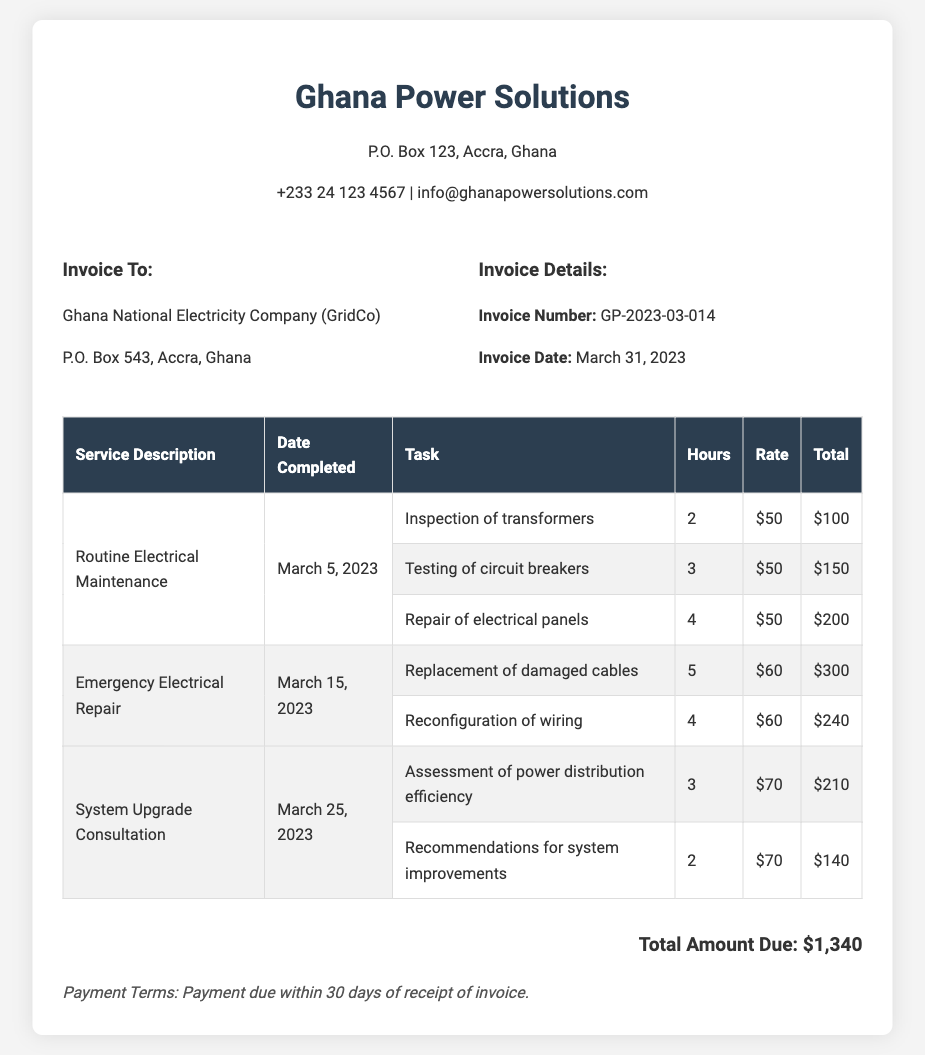What is the invoice number? The invoice number is a unique identifier for the invoice, which can be found in the invoice details section.
Answer: GP-2023-03-014 Who is the invoice addressed to? The invoice is addressed to Ghana National Electricity Company (GridCo) as seen in the invoice details.
Answer: Ghana National Electricity Company (GridCo) What is the total amount due? The total amount due is calculated from all services rendered and is stated at the bottom of the invoice.
Answer: $1,340 How many hours were spent on the inspection of transformers? The hours spent on the inspection of transformers can be found in the service details of the invoice.
Answer: 2 What date was the routine electrical maintenance completed? The date of completion for the routine electrical maintenance is specified in the service description table.
Answer: March 5, 2023 What is the payment term for this invoice? The payment term outlines how long the client has to settle the invoice and is listed at the bottom.
Answer: Payment due within 30 days of receipt of invoice How much was charged for the testing of circuit breakers? The amount charged for testing of circuit breakers can be found in the total column corresponding to that service.
Answer: $150 Which service had the highest total charge? The service with the highest total charge can be determined by comparing the total amounts for each service in the invoice.
Answer: Emergency Electrical Repair How many recommendations for system improvements were included in the system upgrade consultation? The number of recommendations is determined based on the tasks listed under the service description for the system upgrade consultation.
Answer: 1 